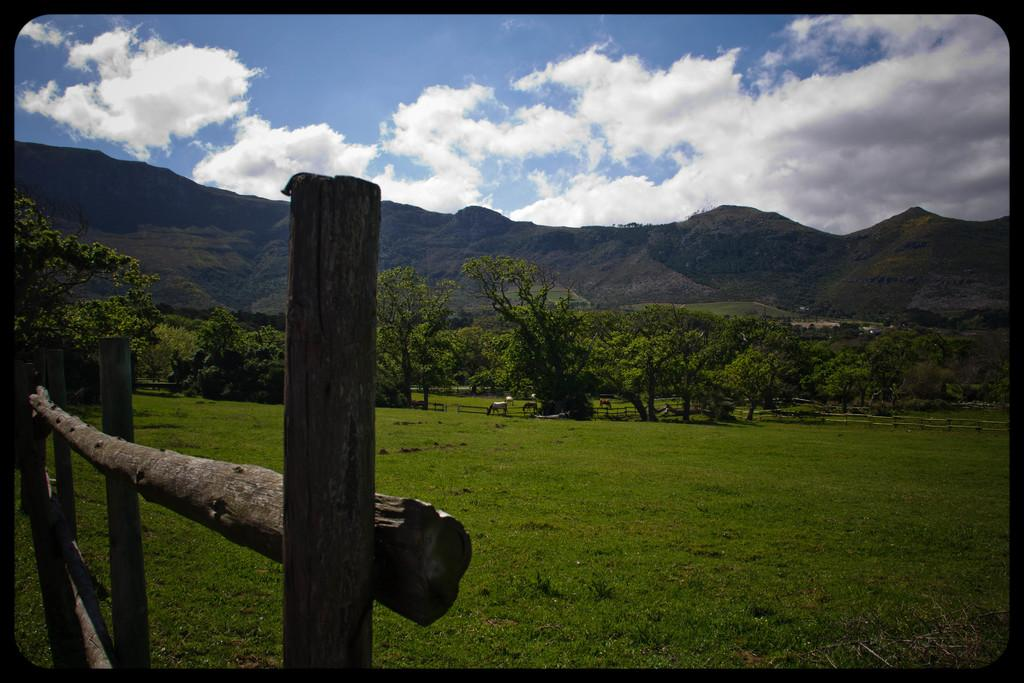What can be observed about the image's appearance? The image appears to be edited. What type of fencing is present in the image? There are wooden fences in the image. What type of living organisms can be seen in the image? There are animals in the image. What type of vegetation is present in the image? There are trees in the image. What type of geographical feature is present in the image? There are hills in the image. What part of the natural environment is visible in the image? The sky is visible in the image. What month is it in the image? The image does not provide any information about the month, as it is a still image and not a representation of a specific time. 